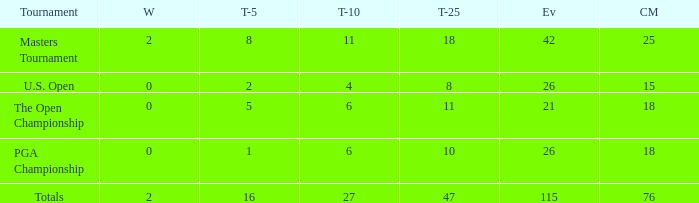What is the total of wins when the cuts made is 76 and the events greater than 115? None. 